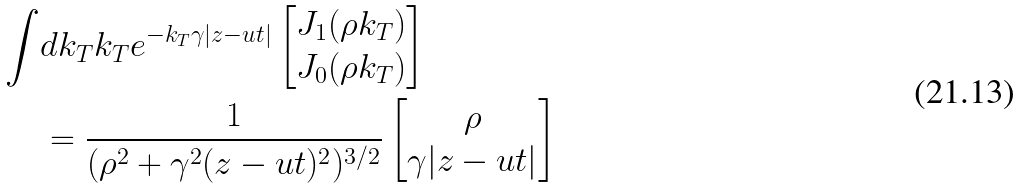Convert formula to latex. <formula><loc_0><loc_0><loc_500><loc_500>\int & d k _ { T } k _ { T } e ^ { - k _ { T } \gamma | z - u t | } \begin{bmatrix} J _ { 1 } ( \rho k _ { T } ) \\ J _ { 0 } ( \rho k _ { T } ) \end{bmatrix} \\ & = \frac { 1 } { ( \rho ^ { 2 } + \gamma ^ { 2 } ( z - u t ) ^ { 2 } ) ^ { 3 / 2 } } \begin{bmatrix} \rho \\ \gamma | z - u t | \end{bmatrix}</formula> 